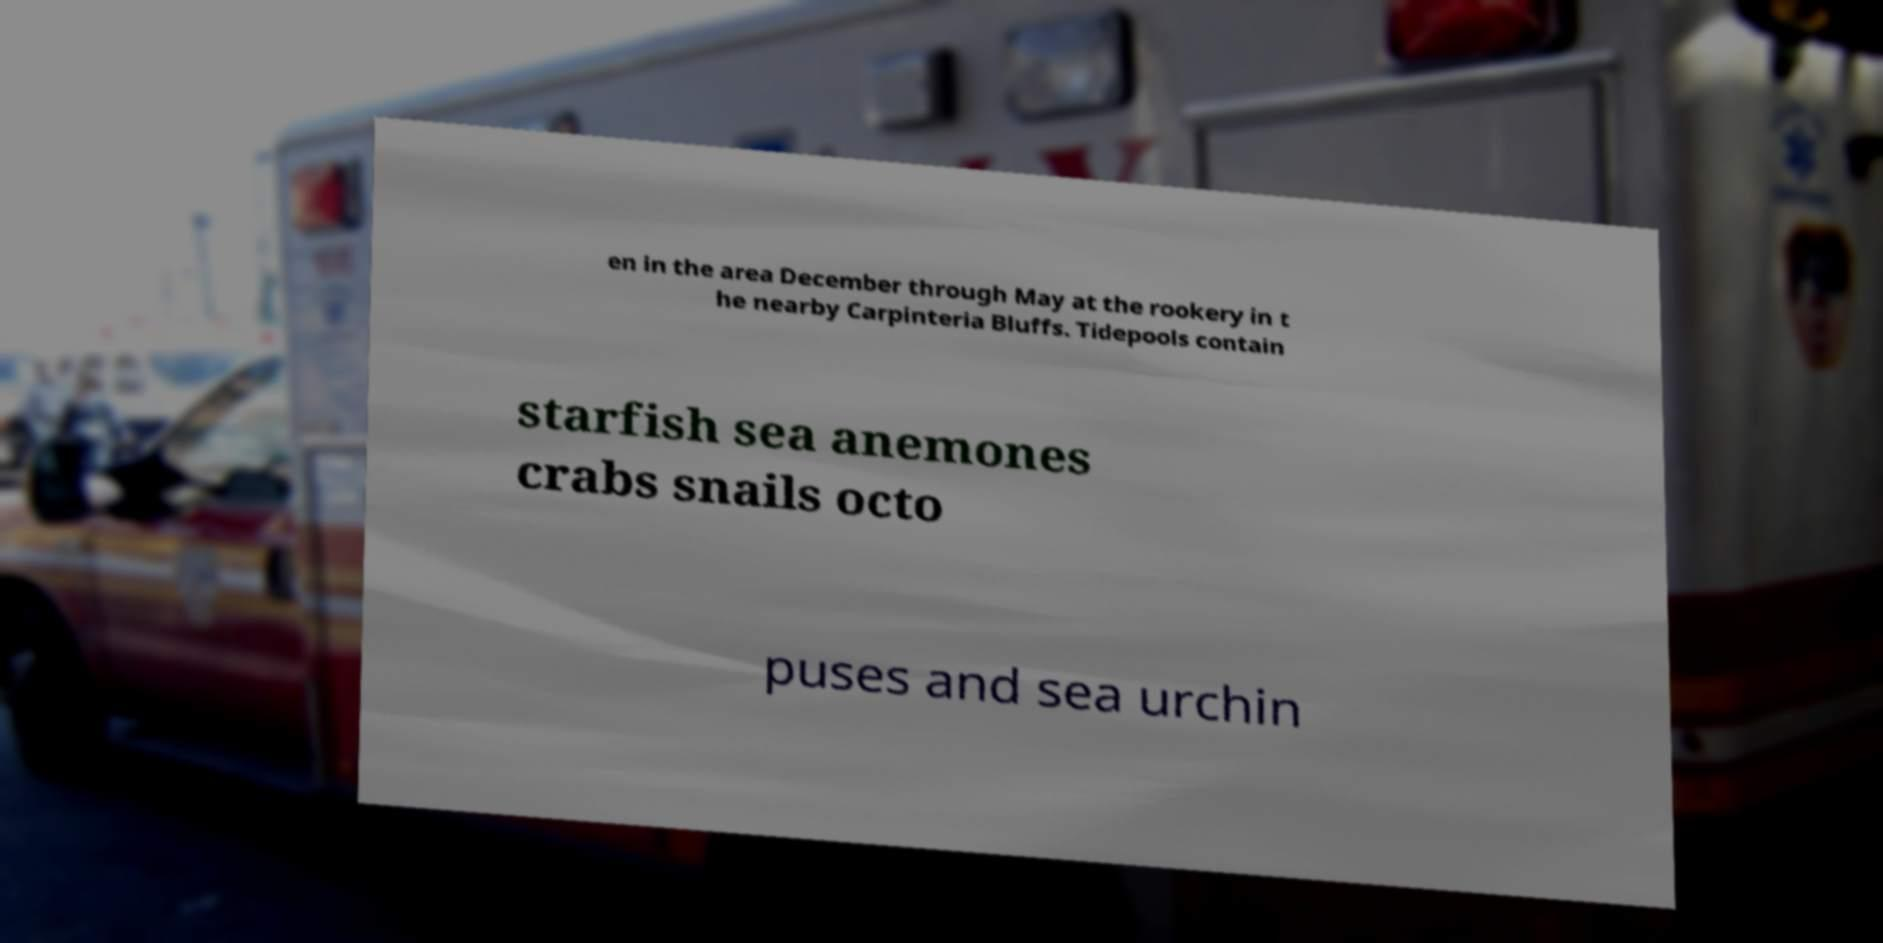For documentation purposes, I need the text within this image transcribed. Could you provide that? en in the area December through May at the rookery in t he nearby Carpinteria Bluffs. Tidepools contain starfish sea anemones crabs snails octo puses and sea urchin 